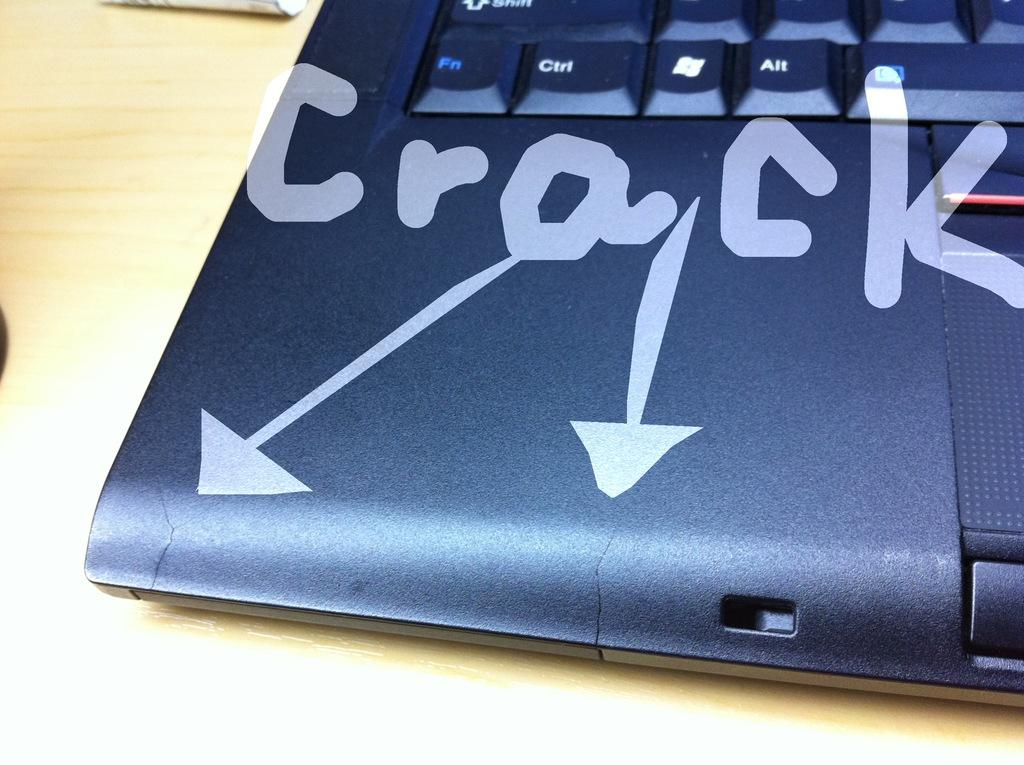<image>
Create a compact narrative representing the image presented. Black laptop with focus on the bottom left, arrows pointing to cracks 